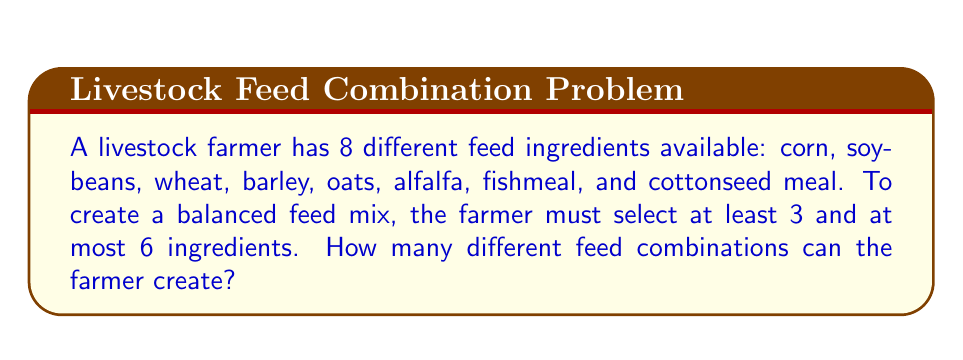What is the answer to this math problem? To solve this problem, we need to use the combination formula for selecting ingredients from the total available options. We'll calculate the number of combinations for selecting 3, 4, 5, and 6 ingredients, then sum these results.

1. For 3 ingredients: $\binom{8}{3}$
2. For 4 ingredients: $\binom{8}{4}$
3. For 5 ingredients: $\binom{8}{5}$
4. For 6 ingredients: $\binom{8}{6}$

Let's calculate each:

1. $\binom{8}{3} = \frac{8!}{3!(8-3)!} = \frac{8!}{3!5!} = 56$
2. $\binom{8}{4} = \frac{8!}{4!(8-4)!} = \frac{8!}{4!4!} = 70$
3. $\binom{8}{5} = \frac{8!}{5!(8-5)!} = \frac{8!}{5!3!} = 56$
4. $\binom{8}{6} = \frac{8!}{6!(8-6)!} = \frac{8!}{6!2!} = 28$

Now, we sum all these combinations:

$$\text{Total combinations} = 56 + 70 + 56 + 28 = 210$$

Therefore, the farmer can create 210 different feed combinations.
Answer: 210 